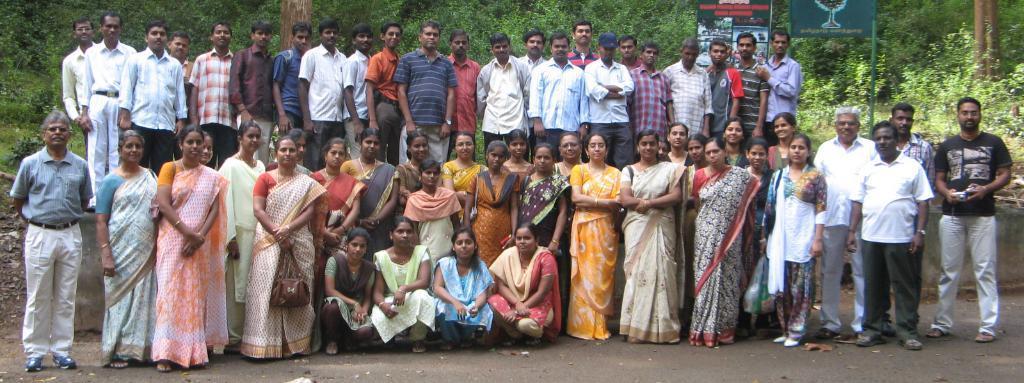How would you summarize this image in a sentence or two? In the picture I can see a group of people standing on the road. There is a man on the extreme right side is wearing a black color T-shirt and he is holding the camera in his hand. I can see a woman on the left side and she is carrying a bag. In the background, I can see the trees and a banner board. 